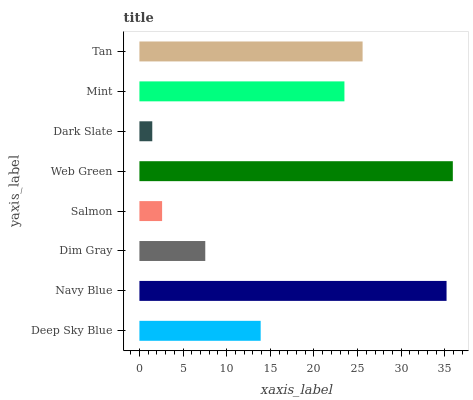Is Dark Slate the minimum?
Answer yes or no. Yes. Is Web Green the maximum?
Answer yes or no. Yes. Is Navy Blue the minimum?
Answer yes or no. No. Is Navy Blue the maximum?
Answer yes or no. No. Is Navy Blue greater than Deep Sky Blue?
Answer yes or no. Yes. Is Deep Sky Blue less than Navy Blue?
Answer yes or no. Yes. Is Deep Sky Blue greater than Navy Blue?
Answer yes or no. No. Is Navy Blue less than Deep Sky Blue?
Answer yes or no. No. Is Mint the high median?
Answer yes or no. Yes. Is Deep Sky Blue the low median?
Answer yes or no. Yes. Is Web Green the high median?
Answer yes or no. No. Is Navy Blue the low median?
Answer yes or no. No. 